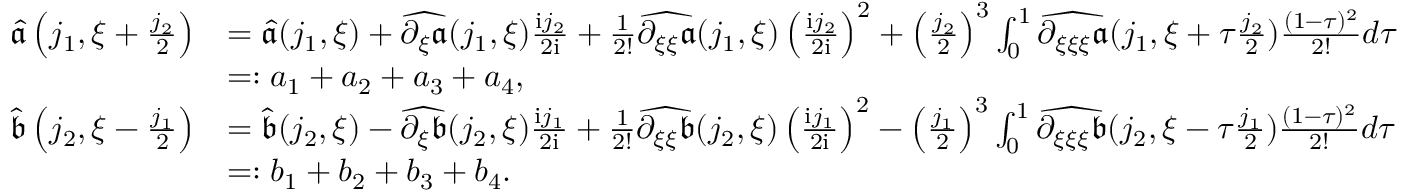<formula> <loc_0><loc_0><loc_500><loc_500>\begin{array} { r l } { \widehat { \mathfrak { a } } \left ( j _ { 1 } , \xi + \frac { j _ { 2 } } 2 \right ) } & { = \widehat { \mathfrak { a } } ( j _ { 1 } , \xi ) + \widehat { \partial _ { \xi } \mathfrak { a } } ( j _ { 1 } , \xi ) \frac { i j _ { 2 } } { 2 i } + \frac { 1 } { 2 ! } \widehat { \partial _ { \xi \xi } \mathfrak { a } } ( j _ { 1 } , \xi ) \left ( \frac { i j _ { 2 } } { 2 i } \right ) ^ { 2 } + \left ( \frac { j _ { 2 } } { 2 } \right ) ^ { 3 } \int _ { 0 } ^ { 1 } \widehat { \partial _ { \xi \xi \xi } \mathfrak { a } } ( j _ { 1 } , \xi + \tau \frac { j _ { 2 } } 2 ) \frac { ( 1 - \tau ) ^ { 2 } } { 2 ! } d \tau } \\ & { = \colon a _ { 1 } + a _ { 2 } + a _ { 3 } + a _ { 4 } , } \\ { \widehat { \mathfrak { b } } \left ( j _ { 2 } , \xi - \frac { j _ { 1 } } 2 \right ) } & { = \widehat { \mathfrak { b } } ( j _ { 2 } , \xi ) - \widehat { \partial _ { \xi } \mathfrak { b } } ( j _ { 2 } , \xi ) \frac { i j _ { 1 } } { 2 i } + \frac { 1 } { 2 ! } \widehat { \partial _ { \xi \xi } \mathfrak { b } } ( j _ { 2 } , \xi ) \left ( \frac { i j _ { 1 } } { 2 i } \right ) ^ { 2 } - \left ( \frac { j _ { 1 } } { 2 } \right ) ^ { 3 } \int _ { 0 } ^ { 1 } \widehat { \partial _ { \xi \xi \xi } \mathfrak { b } } ( j _ { 2 } , \xi - \tau \frac { j _ { 1 } } 2 ) \frac { ( 1 - \tau ) ^ { 2 } } { 2 ! } d \tau } \\ & { = \colon b _ { 1 } + b _ { 2 } + b _ { 3 } + b _ { 4 } . } \end{array}</formula> 